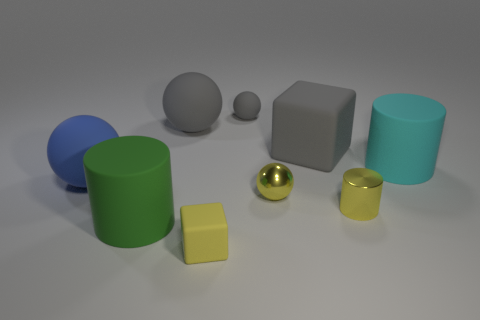Subtract all spheres. How many objects are left? 5 Subtract 0 brown cubes. How many objects are left? 9 Subtract all spheres. Subtract all tiny things. How many objects are left? 1 Add 4 matte balls. How many matte balls are left? 7 Add 9 big gray blocks. How many big gray blocks exist? 10 